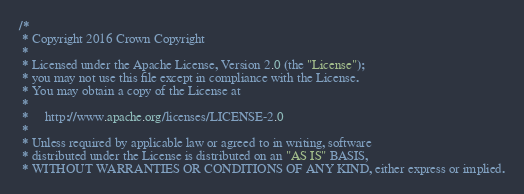<code> <loc_0><loc_0><loc_500><loc_500><_CSS_>/*
 * Copyright 2016 Crown Copyright
 *
 * Licensed under the Apache License, Version 2.0 (the "License");
 * you may not use this file except in compliance with the License.
 * You may obtain a copy of the License at
 *
 *     http://www.apache.org/licenses/LICENSE-2.0
 *
 * Unless required by applicable law or agreed to in writing, software
 * distributed under the License is distributed on an "AS IS" BASIS,
 * WITHOUT WARRANTIES OR CONDITIONS OF ANY KIND, either express or implied.</code> 